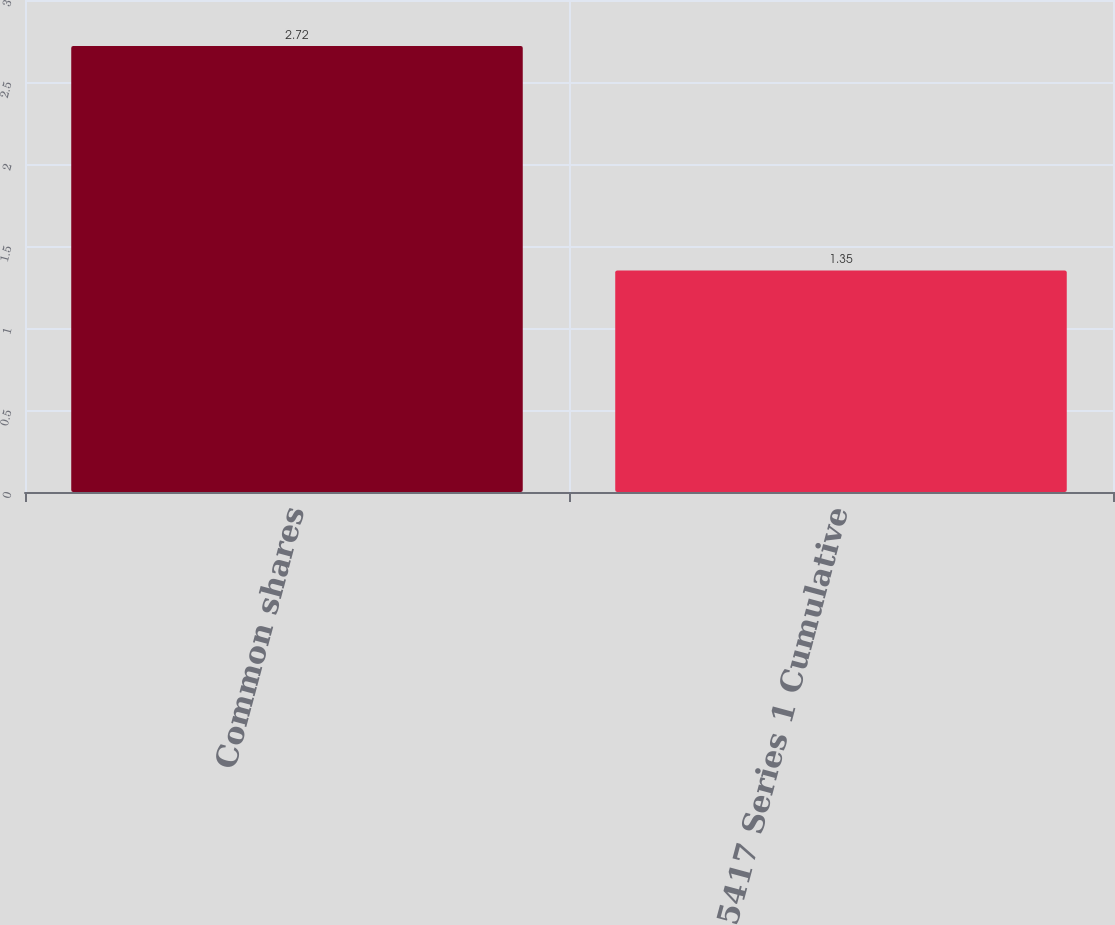Convert chart to OTSL. <chart><loc_0><loc_0><loc_500><loc_500><bar_chart><fcel>Common shares<fcel>5417 Series 1 Cumulative<nl><fcel>2.72<fcel>1.35<nl></chart> 